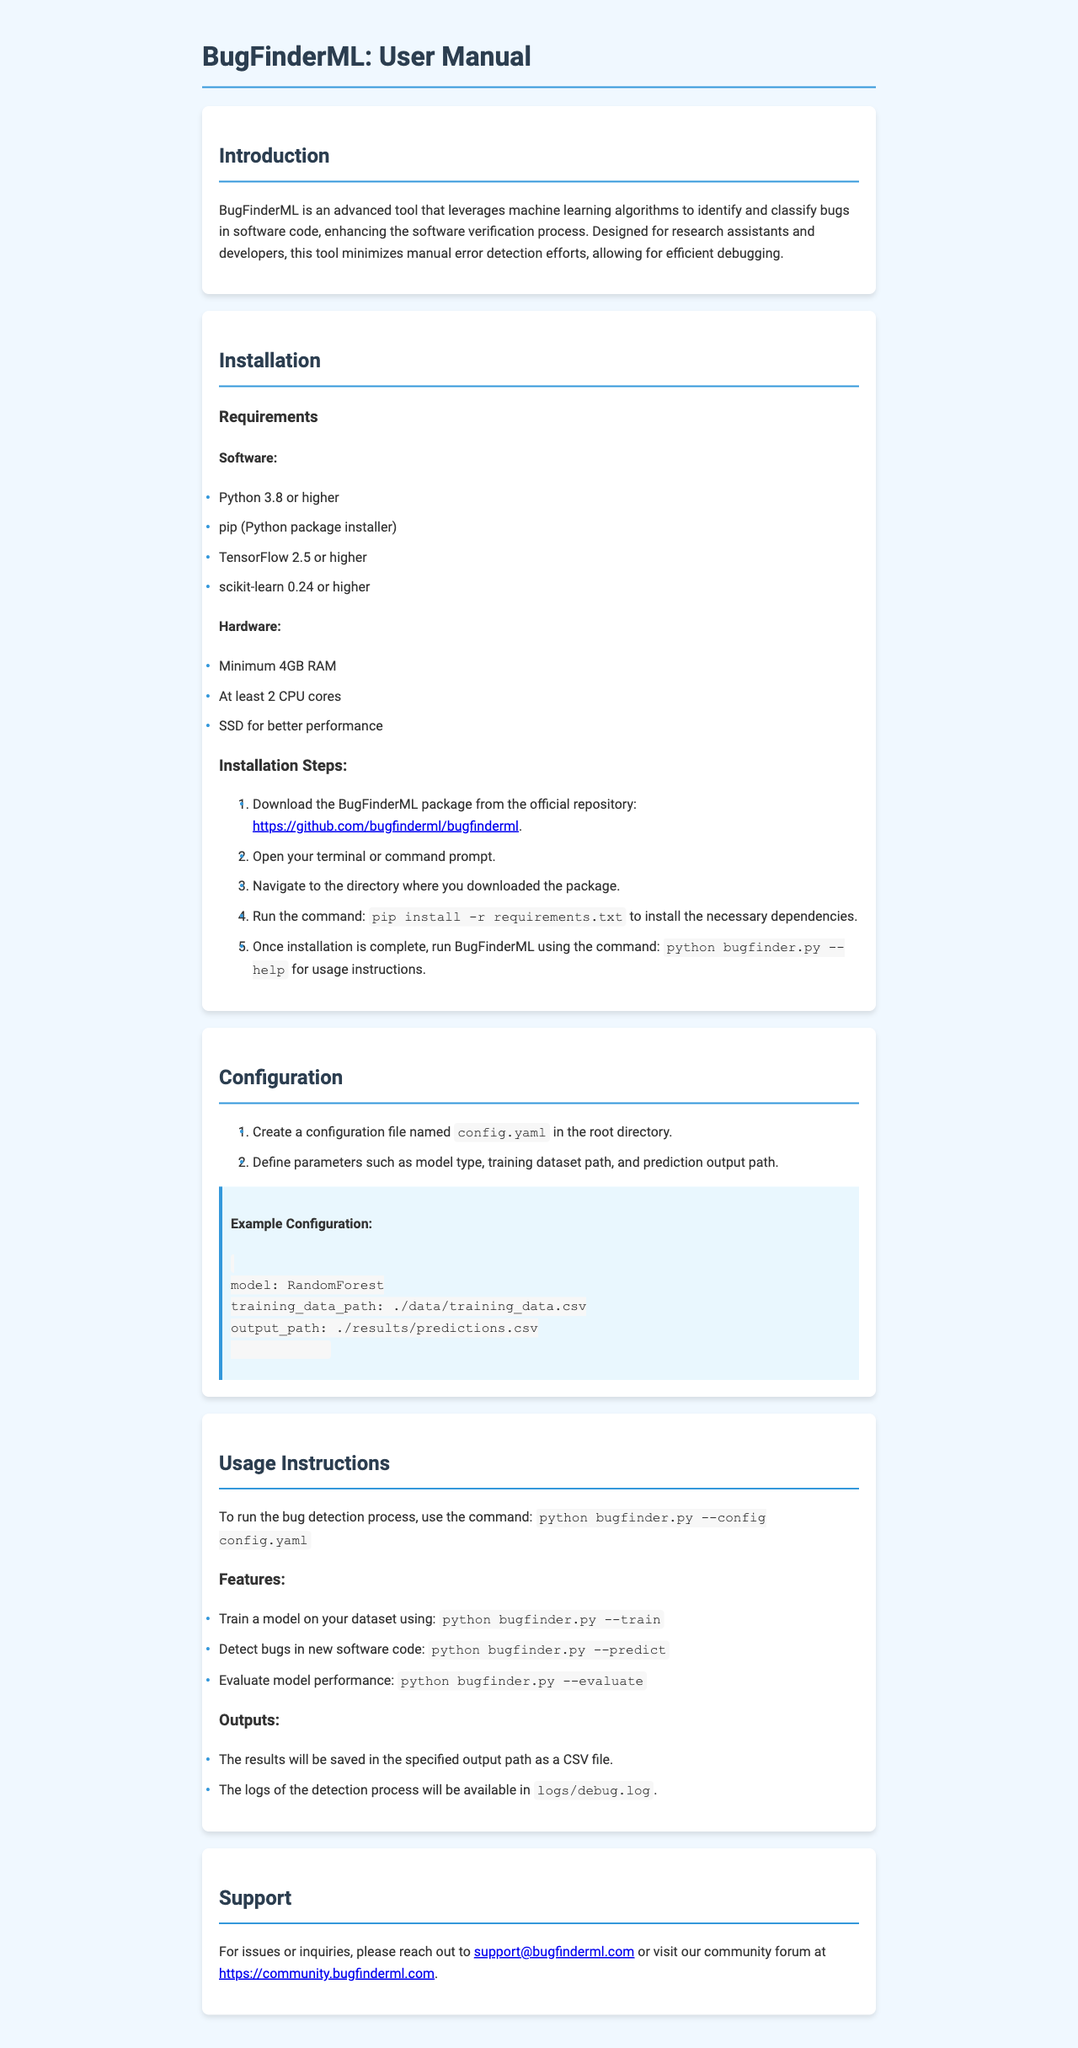What is the minimum RAM requirement? The document specifies that the minimum RAM requirement for BugFinderML is 4GB.
Answer: 4GB What command installs the necessary dependencies? To install the necessary dependencies, the command provided in the installation steps is included in the document.
Answer: pip install -r requirements.txt What file should be created for configuration? The configuration section mentions creating a specific file for setting parameters.
Answer: config.yaml Which model type is suggested in the example configuration? The example configuration presents a specific model type that can be used, which is detailed in the document.
Answer: RandomForest What is the output file format for predictions? The document states that the results will be saved in a specific format, which is mentioned in the outputs section.
Answer: CSV file What is the command to evaluate model performance? The usage instructions section provides a command for evaluating model performance, which is specific and detailed in the document.
Answer: python bugfinder.py --evaluate Where will the logs of the detection process be saved? The document specifies the location where the logs of the detection process will be available.
Answer: logs/debug.log What version of TensorFlow is required? The requirements section of the installation outlines the necessary software, which includes a specific version of TensorFlow.
Answer: 2.5 or higher 